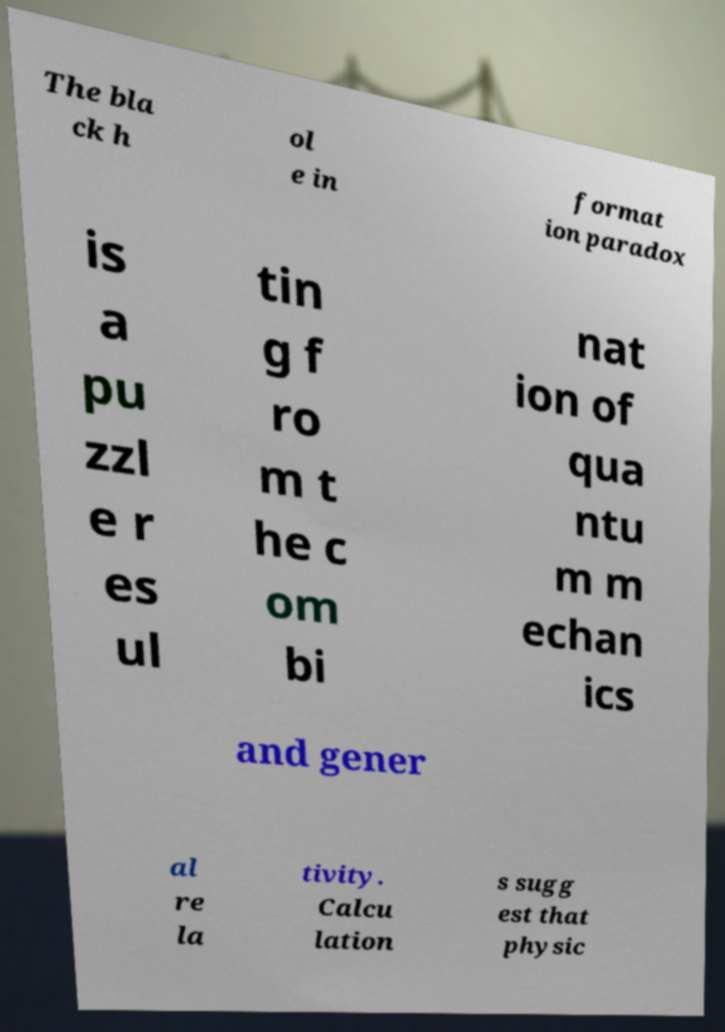I need the written content from this picture converted into text. Can you do that? The bla ck h ol e in format ion paradox is a pu zzl e r es ul tin g f ro m t he c om bi nat ion of qua ntu m m echan ics and gener al re la tivity. Calcu lation s sugg est that physic 